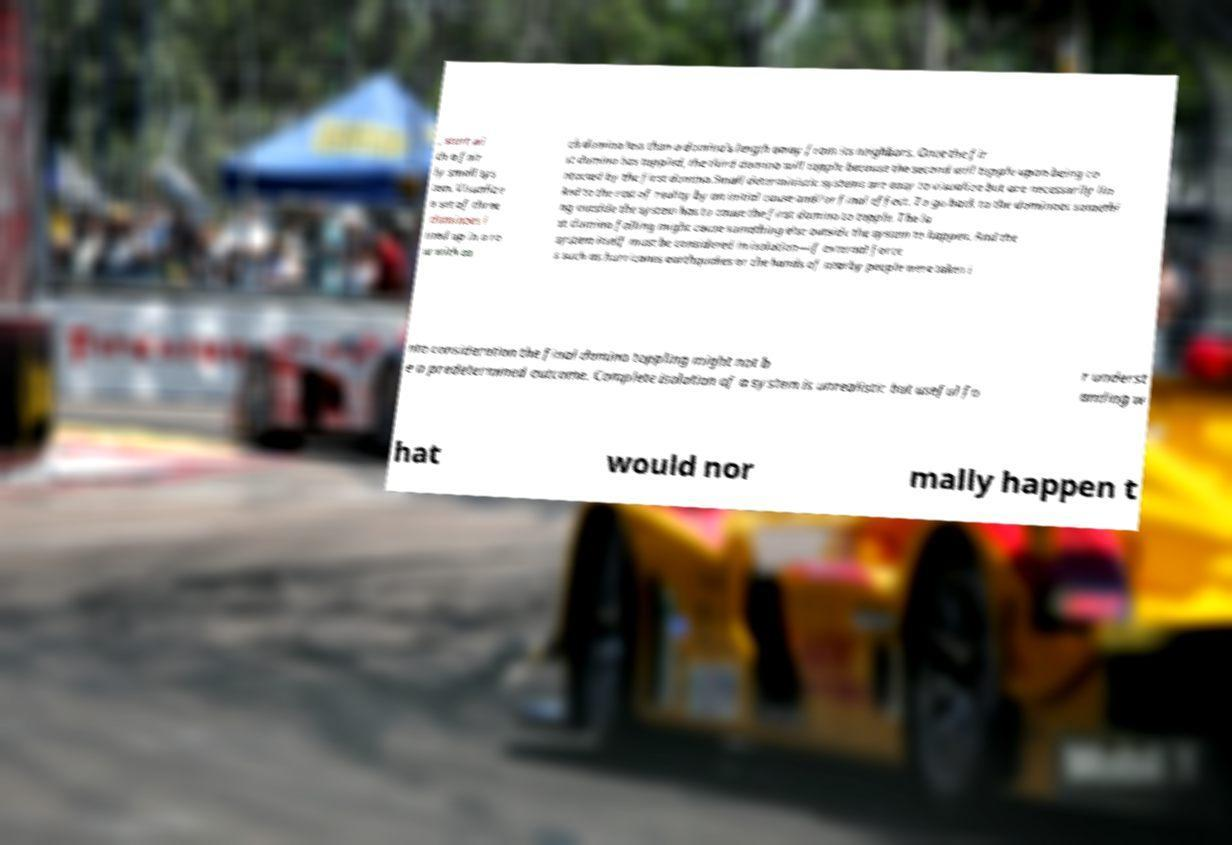What messages or text are displayed in this image? I need them in a readable, typed format. , start wi th a fair ly small sys tem. Visualize a set of three dominoes l ined up in a ro w with ea ch domino less than a domino's length away from its neighbors. Once the fir st domino has toppled, the third domino will topple because the second will topple upon being co ntacted by the first domino.Small deterministic systems are easy to visualize but are necessarily lin ked to the rest of reality by an initial cause and/or final effect. To go back to the dominoes somethi ng outside the system has to cause the first domino to topple. The la st domino falling might cause something else outside the system to happen. And the system itself must be considered in isolation—if external force s such as hurricanes earthquakes or the hands of nearby people were taken i nto consideration the final domino toppling might not b e a predetermined outcome. Complete isolation of a system is unrealistic but useful fo r underst anding w hat would nor mally happen t 